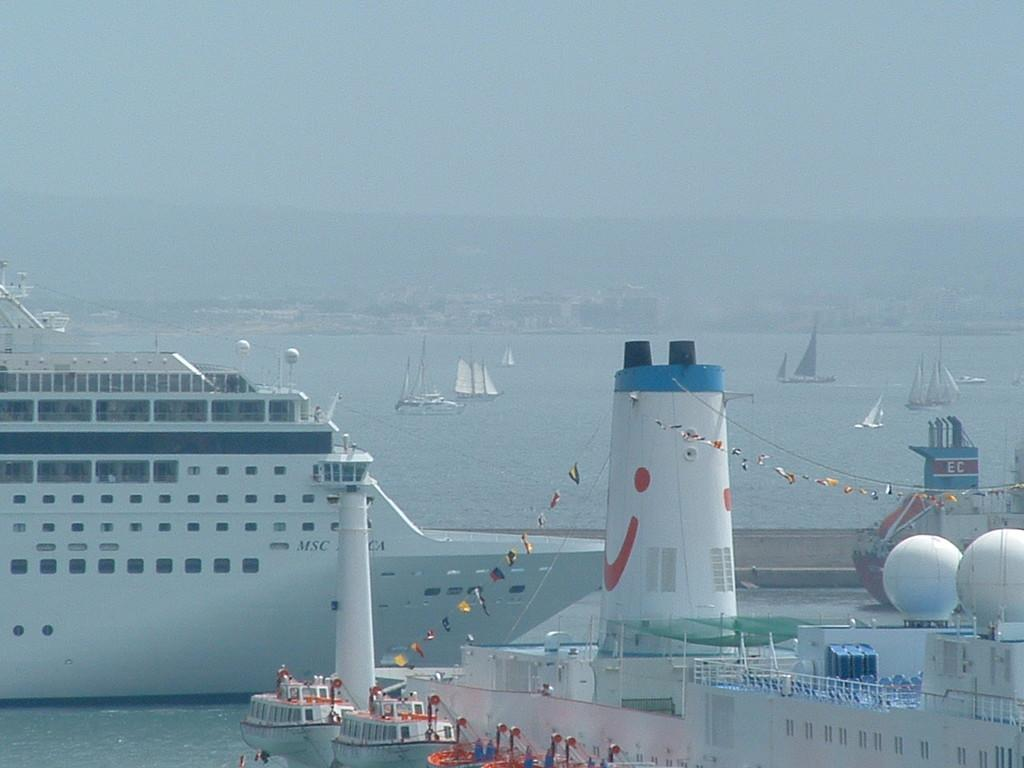What type of vehicles are present in the image? There are boats and ships in the image. Where are the boats and ships located? They are on the water in the image. What can be seen in the background of the image? There are houses, mountains, and the sky visible in the background of the image. What color is the crayon used to draw the impulse in the image? There is no crayon or impulse present in the image. What type of work is being done by the people in the image? There are no people visible in the image, so it is not possible to determine what type of work they might be doing. 